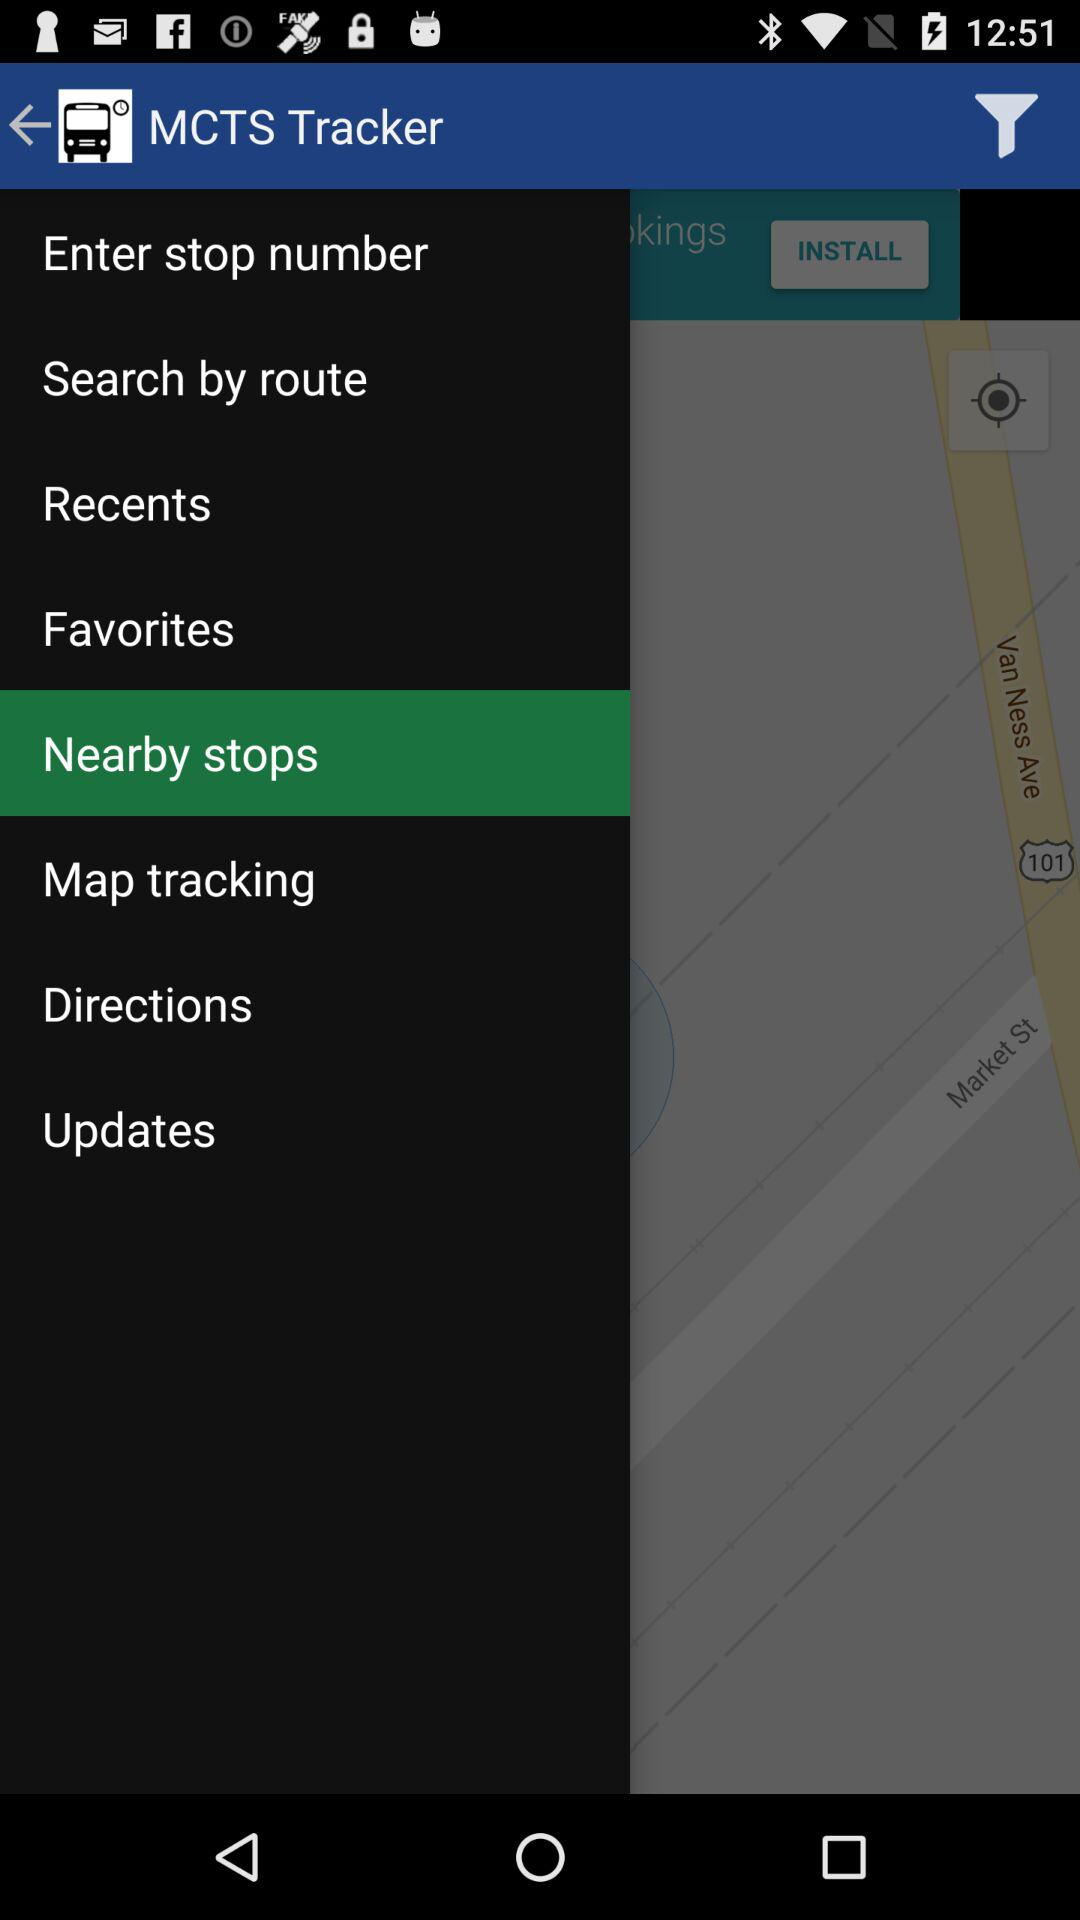Which option is selected? The selected option is "Nearby stops". 